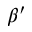<formula> <loc_0><loc_0><loc_500><loc_500>\beta ^ { \prime }</formula> 